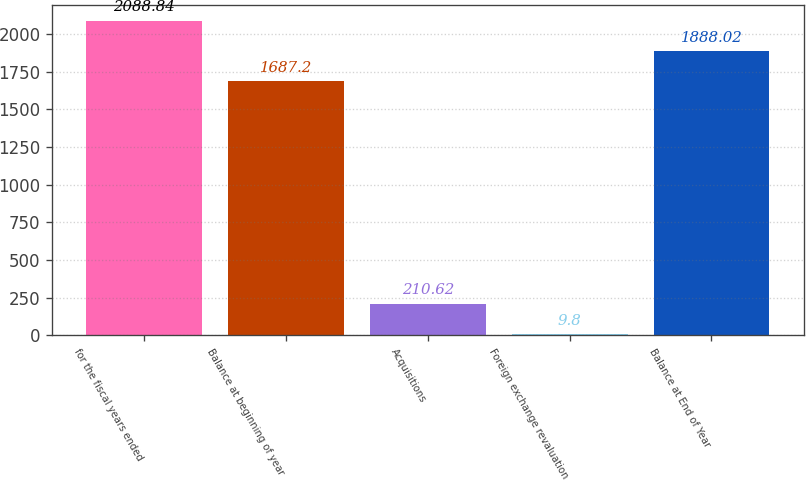Convert chart to OTSL. <chart><loc_0><loc_0><loc_500><loc_500><bar_chart><fcel>for the fiscal years ended<fcel>Balance at beginning of year<fcel>Acquisitions<fcel>Foreign exchange revaluation<fcel>Balance at End of Year<nl><fcel>2088.84<fcel>1687.2<fcel>210.62<fcel>9.8<fcel>1888.02<nl></chart> 